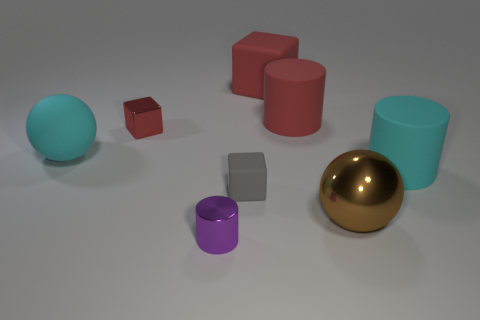Can you describe the different colors and materials of the objects in the image? Certainly! The image features objects with varying colors and textures. There's a large brown metallic sphere that has a shiny surface, and a teal-colored sphere with a matte finish. The cylinders appear to have a matte surface as well, with one being pastel teal and the other a muted purple. The cube is glossy and red whereas the small cube is a matte brick color. Lastly, the rectangular block has a plain gray color with a matte surface texture. 